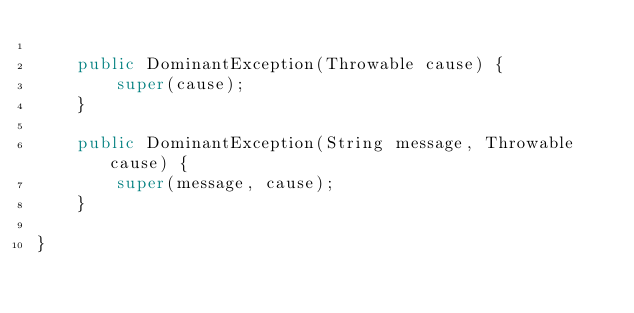Convert code to text. <code><loc_0><loc_0><loc_500><loc_500><_Java_>
    public DominantException(Throwable cause) {
        super(cause);
    }

    public DominantException(String message, Throwable cause) {
        super(message, cause);
    }

}
</code> 